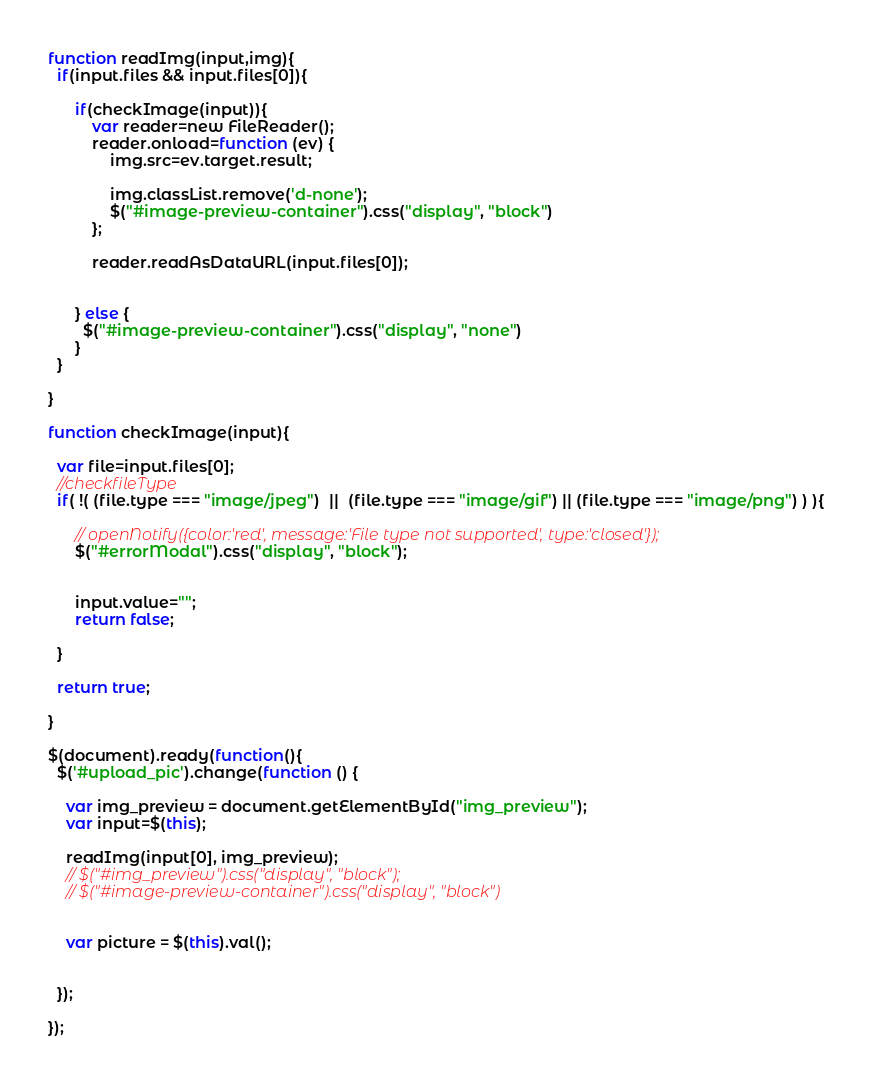<code> <loc_0><loc_0><loc_500><loc_500><_JavaScript_>


function readImg(input,img){
  if(input.files && input.files[0]){

      if(checkImage(input)){
          var reader=new FileReader();
          reader.onload=function (ev) {
              img.src=ev.target.result;
                           
              img.classList.remove('d-none');
              $("#image-preview-container").css("display", "block")
          };

          reader.readAsDataURL(input.files[0]);


      } else {
        $("#image-preview-container").css("display", "none")
      }
  }

}

function checkImage(input){

  var file=input.files[0];
  //checkfileType
  if( !( (file.type === "image/jpeg")  ||  (file.type === "image/gif") || (file.type === "image/png") ) ){

      // openNotify({color:'red', message:'File type not supported', type:'closed'});
      $("#errorModal").css("display", "block");
      
      
      input.value="";
      return false;

  }

  return true;

}

$(document).ready(function(){
  $('#upload_pic').change(function () {

    var img_preview = document.getElementById("img_preview");
    var input=$(this);

    readImg(input[0], img_preview);
    // $("#img_preview").css("display", "block");
    // $("#image-preview-container").css("display", "block")

    
    var picture = $(this).val();
    
    
  });

});

</code> 